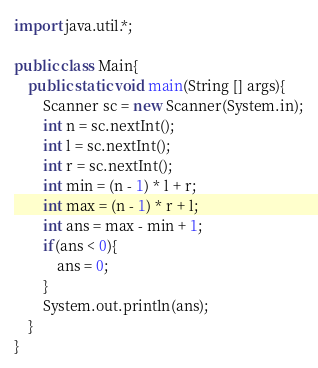<code> <loc_0><loc_0><loc_500><loc_500><_Java_>import java.util.*;

public class Main{
    public static void main(String [] args){
        Scanner sc = new Scanner(System.in);
        int n = sc.nextInt();
        int l = sc.nextInt();
        int r = sc.nextInt();
        int min = (n - 1) * l + r;
        int max = (n - 1) * r + l;
        int ans = max - min + 1;
        if(ans < 0){
            ans = 0;
        }
        System.out.println(ans);
    }
}
</code> 